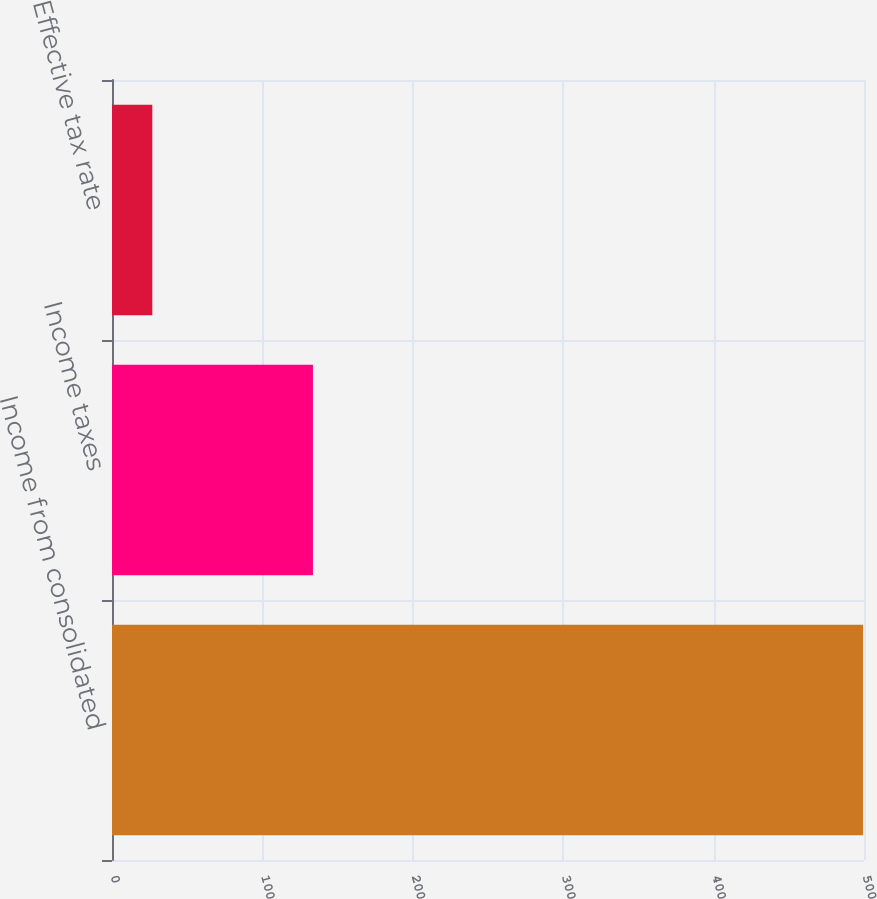Convert chart. <chart><loc_0><loc_0><loc_500><loc_500><bar_chart><fcel>Income from consolidated<fcel>Income taxes<fcel>Effective tax rate<nl><fcel>499.4<fcel>133.6<fcel>26.8<nl></chart> 